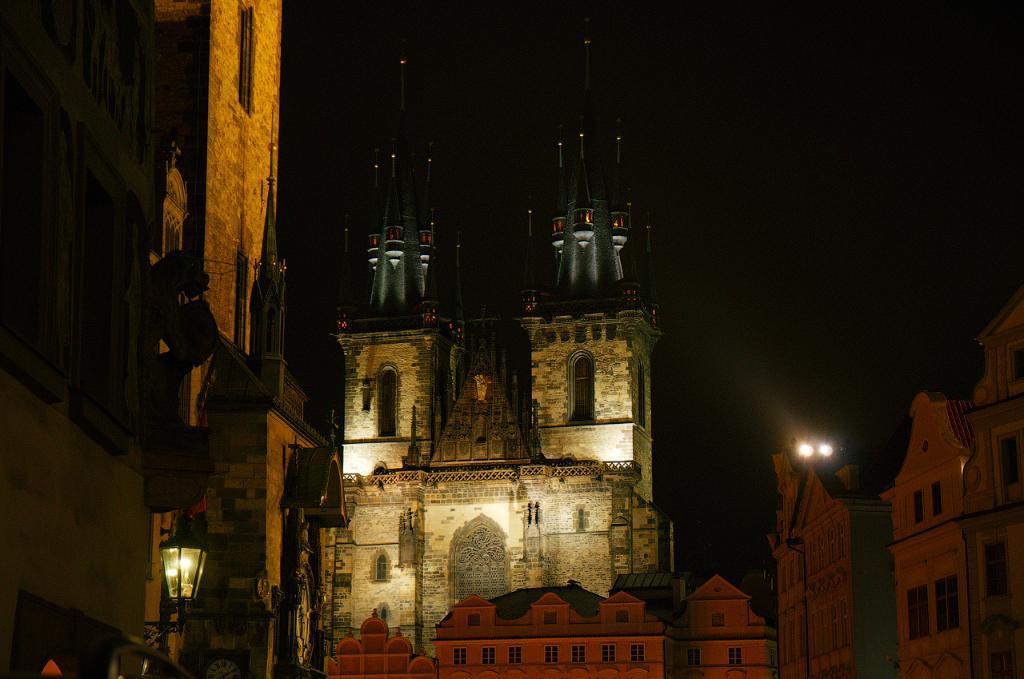How would you summarize this image in a sentence or two? In the picture there are buildings, there are lights, there is a dark sky. 